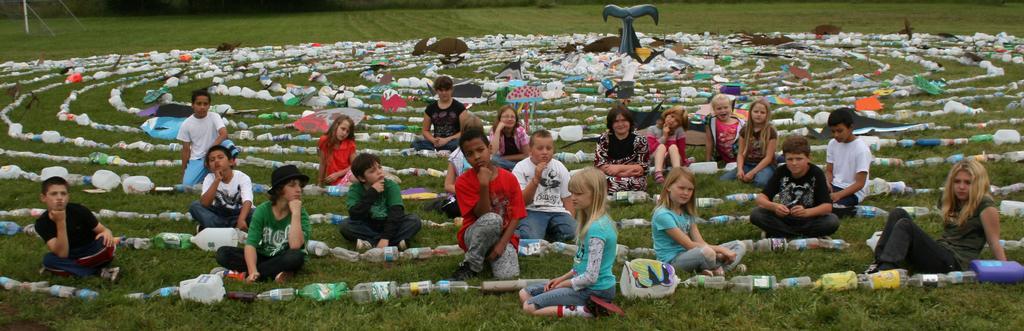In one or two sentences, can you explain what this image depicts? In this picture we can see some kids sitting on the ground, at the bottom there is grass, we can see bottles here, there is a statue in the middle, on the left side there is a pole. 